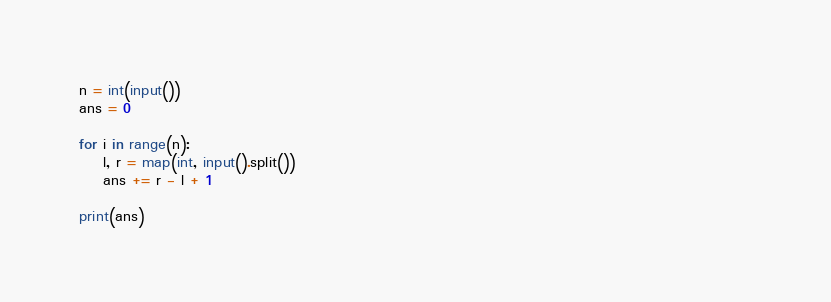<code> <loc_0><loc_0><loc_500><loc_500><_Python_>n = int(input())
ans = 0
                                                                                                                  
for i in range(n):
    l, r = map(int, input().split())
    ans += r - l + 1

print(ans)</code> 